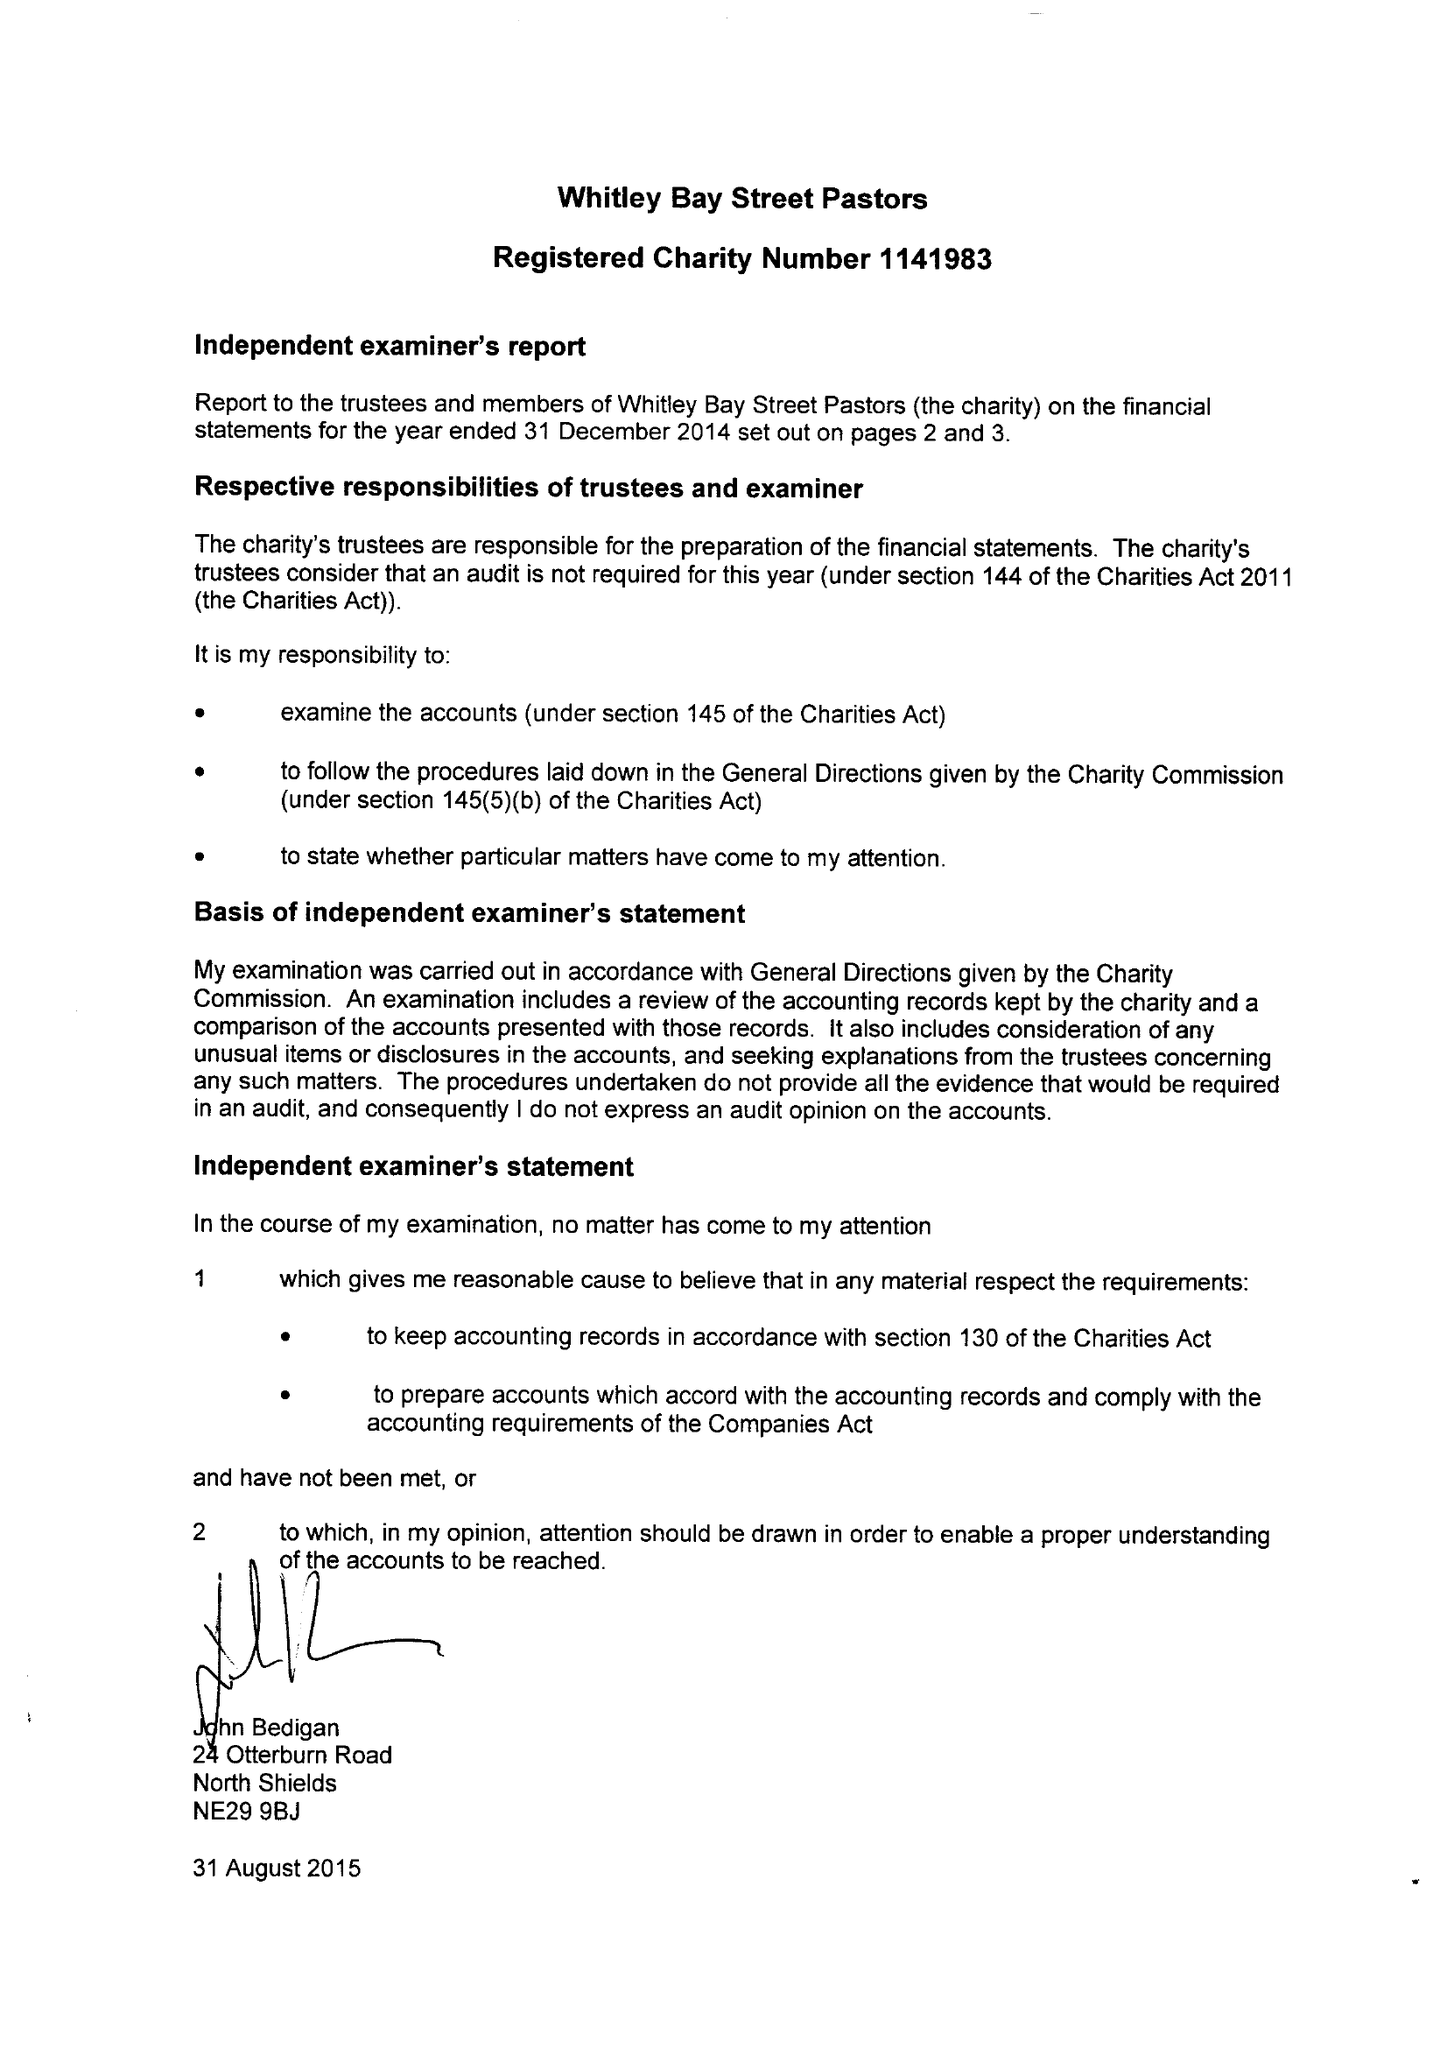What is the value for the address__post_town?
Answer the question using a single word or phrase. WHITLEY BAY 